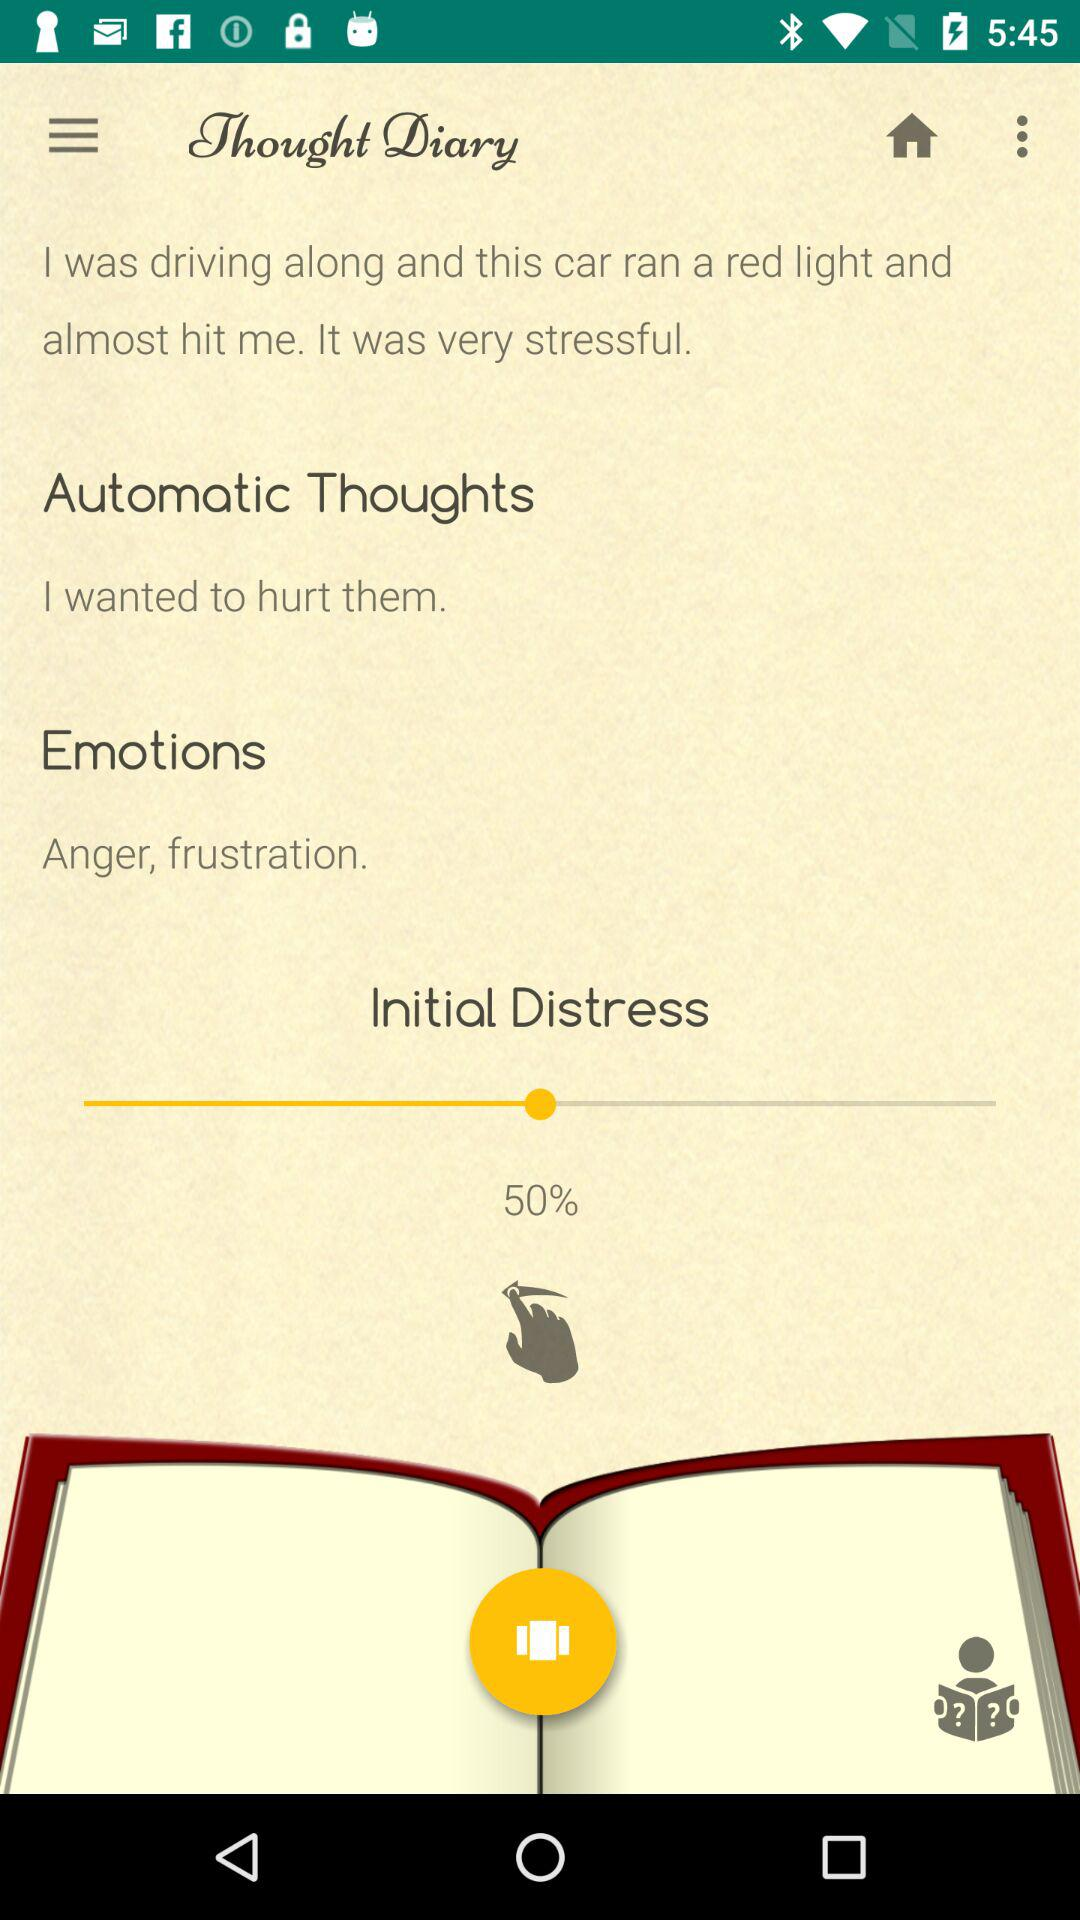What percentage of initial distress is the person currently experiencing?
Answer the question using a single word or phrase. 50% 